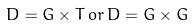<formula> <loc_0><loc_0><loc_500><loc_500>D = G \times T \, o r \, D = G \times G</formula> 